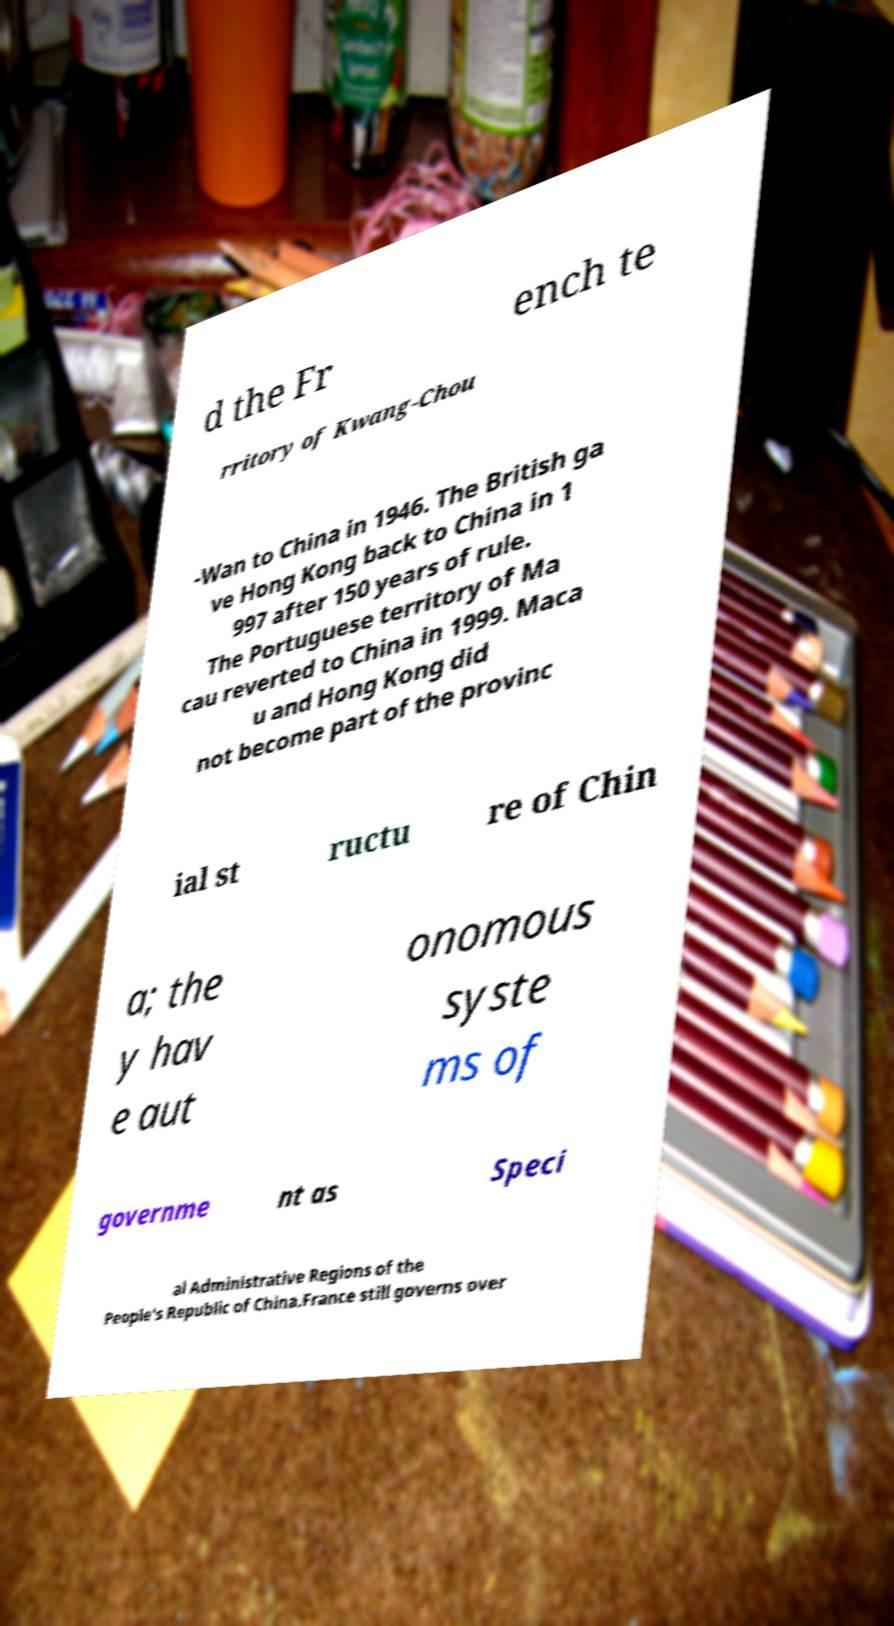Can you accurately transcribe the text from the provided image for me? d the Fr ench te rritory of Kwang-Chou -Wan to China in 1946. The British ga ve Hong Kong back to China in 1 997 after 150 years of rule. The Portuguese territory of Ma cau reverted to China in 1999. Maca u and Hong Kong did not become part of the provinc ial st ructu re of Chin a; the y hav e aut onomous syste ms of governme nt as Speci al Administrative Regions of the People's Republic of China.France still governs over 